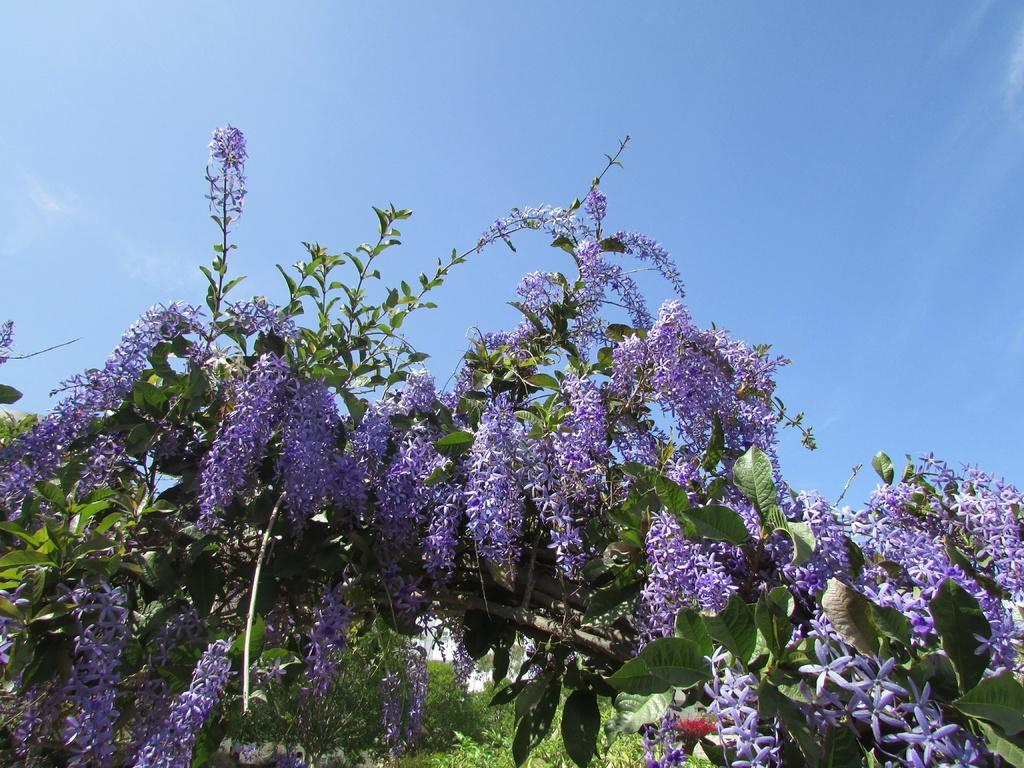What type of plants can be seen in the image? There are flowers in the image. What color are the flowers? The flowers are in brinjal color. Where are the flowers located? The flowers are on trees. What is visible at the top of the image? The sky is visible at the top of the image. What type of chalk is being used to draw on the rail in the image? There is no chalk or rail present in the image; it features flowers on trees with a visible sky. 